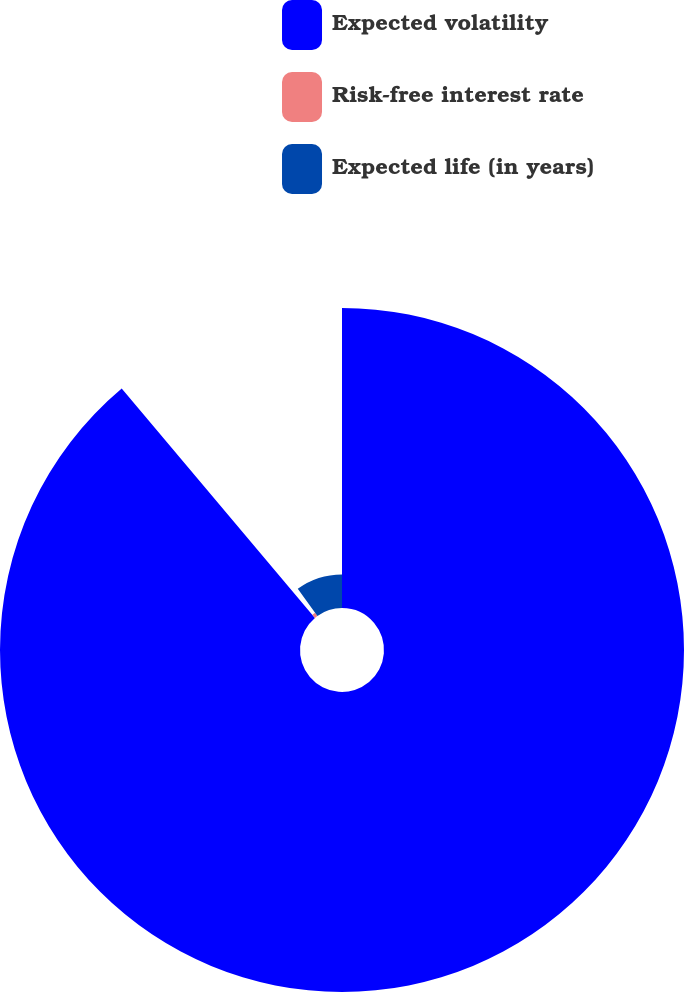Convert chart to OTSL. <chart><loc_0><loc_0><loc_500><loc_500><pie_chart><fcel>Expected volatility<fcel>Risk-free interest rate<fcel>Expected life (in years)<nl><fcel>88.86%<fcel>1.19%<fcel>9.95%<nl></chart> 